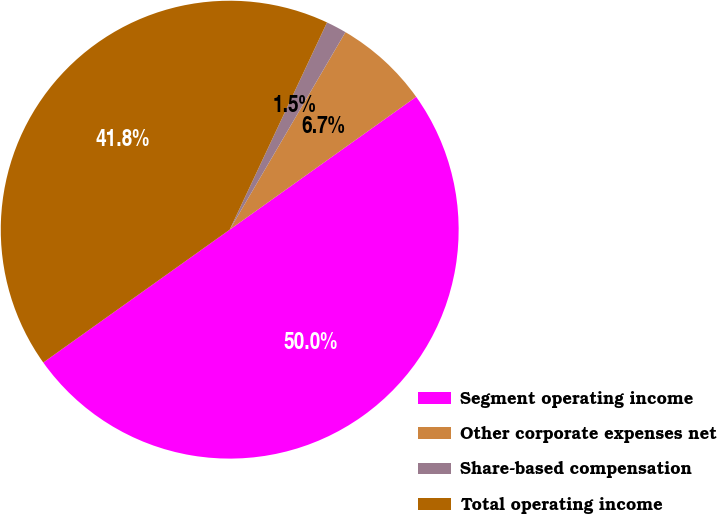Convert chart to OTSL. <chart><loc_0><loc_0><loc_500><loc_500><pie_chart><fcel>Segment operating income<fcel>Other corporate expenses net<fcel>Share-based compensation<fcel>Total operating income<nl><fcel>50.0%<fcel>6.71%<fcel>1.45%<fcel>41.84%<nl></chart> 